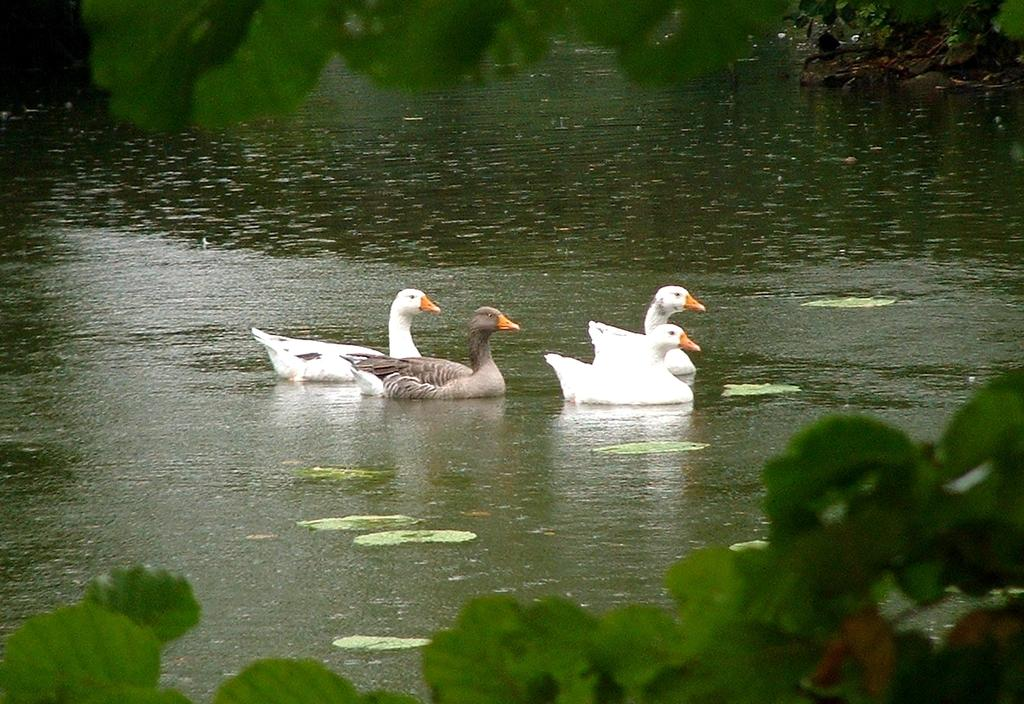What types of ducks can be seen in the image? There are white and brown color ducks in the image. What are the ducks doing in the image? The ducks are swimming in the pond water. What type of vegetation can be seen in the image? There are green leaves visible in the image. What type of crack can be seen in the image? There is no crack present in the image; it features ducks swimming in a pond and green leaves. Is there a scarecrow visible in the image? No, there is no scarecrow present in the image. 